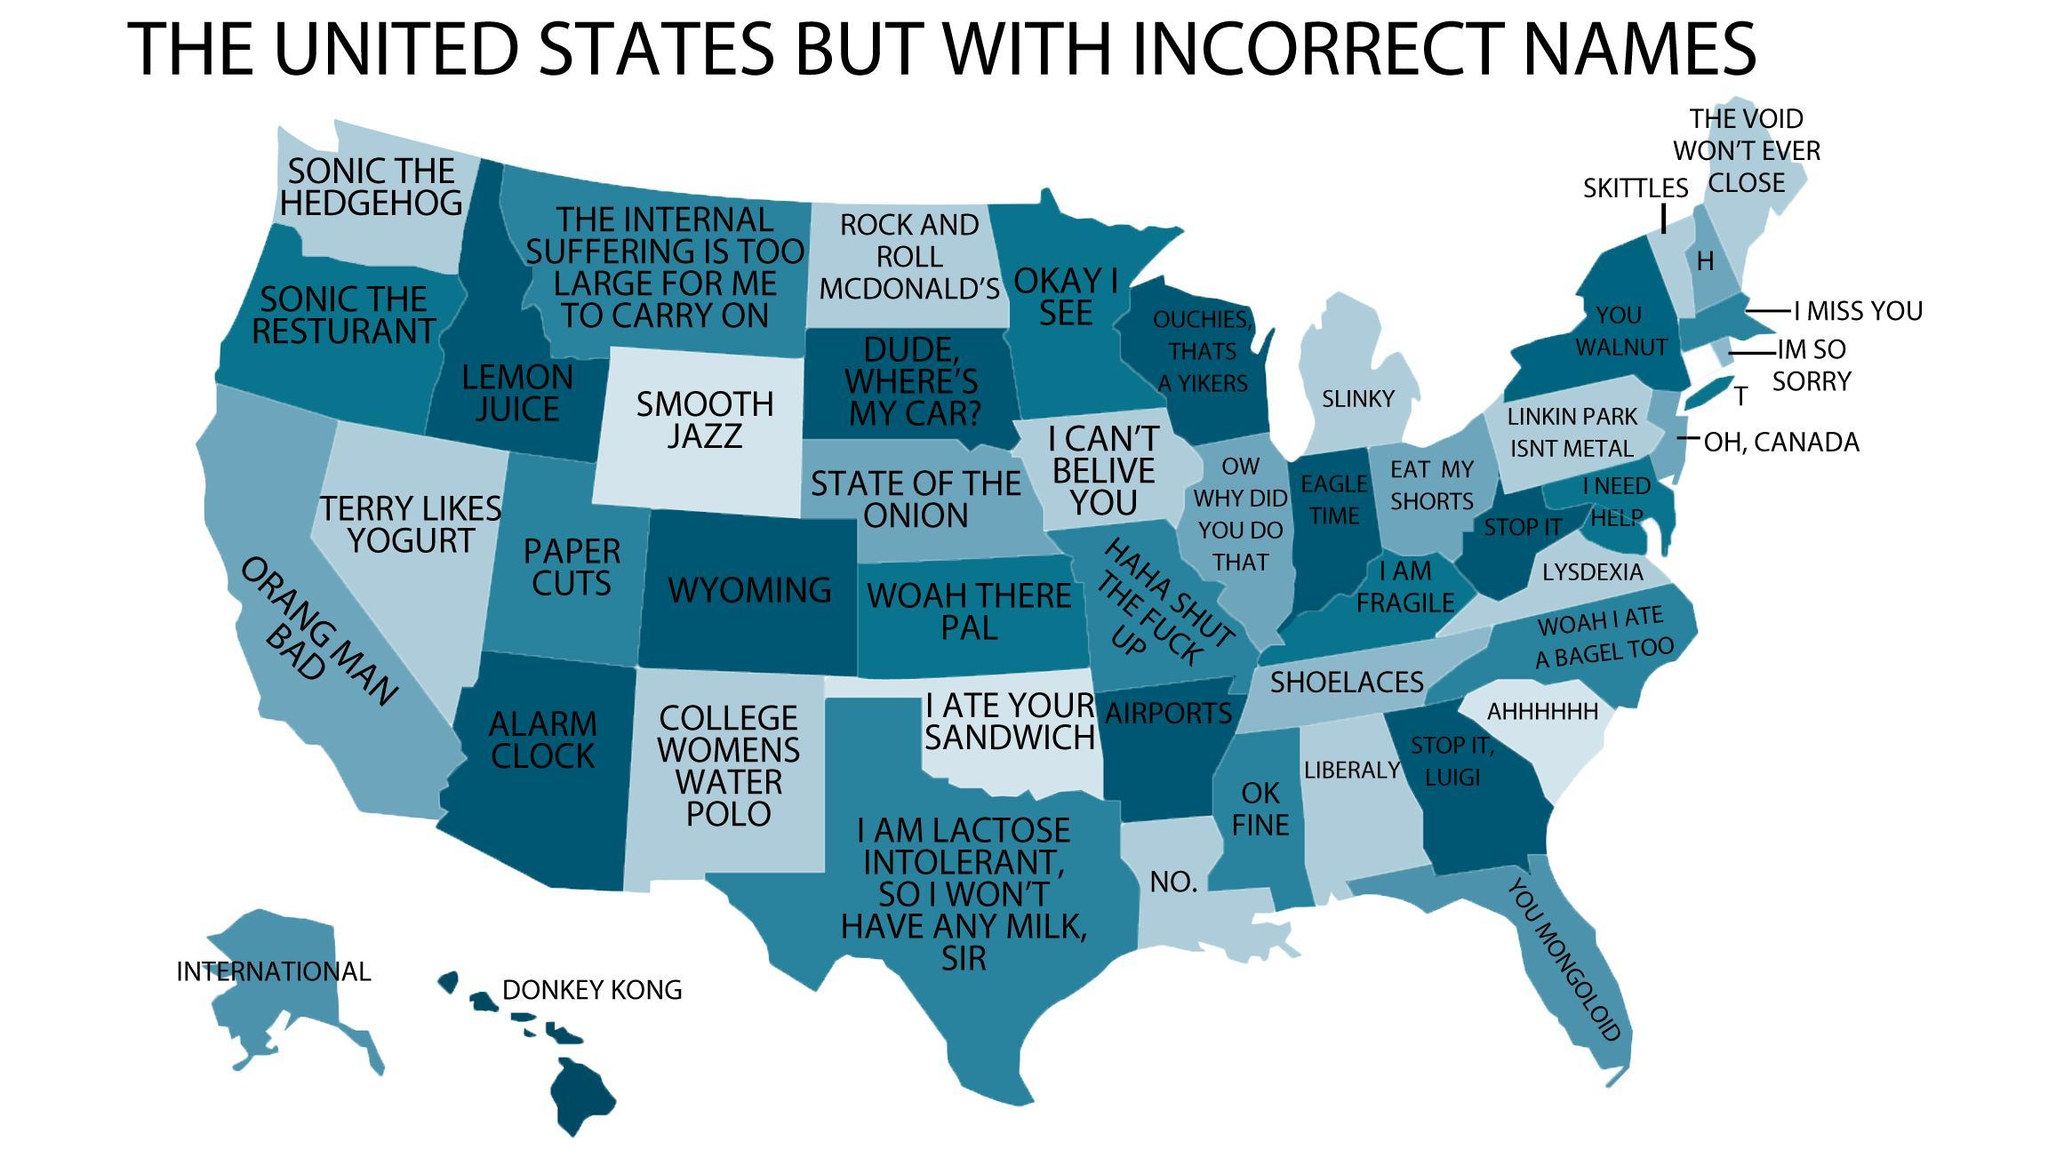How many state has incorrect names on the map ?
Answer the question with a short phrase. 49 Which is the only state that has the correct name ? Wyoming 